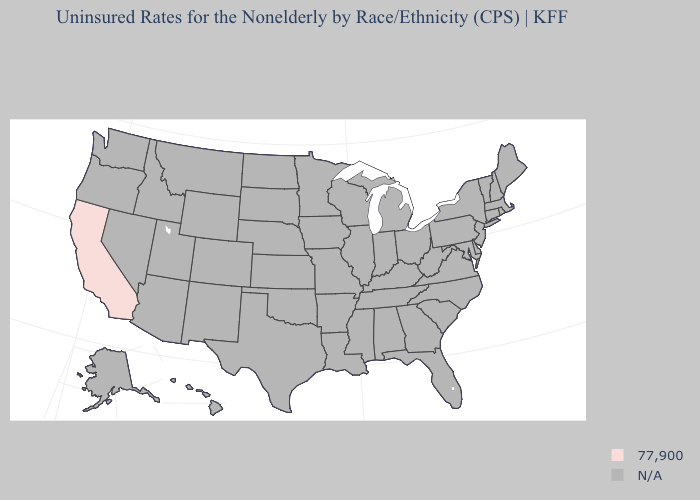Does the map have missing data?
Write a very short answer. Yes. Name the states that have a value in the range 77,900?
Be succinct. California. What is the value of Connecticut?
Short answer required. N/A. What is the value of Ohio?
Quick response, please. N/A. How many symbols are there in the legend?
Answer briefly. 2. Does the first symbol in the legend represent the smallest category?
Be succinct. Yes. Name the states that have a value in the range 77,900?
Give a very brief answer. California. What is the highest value in the USA?
Be succinct. 77,900. Name the states that have a value in the range 77,900?
Quick response, please. California. How many symbols are there in the legend?
Give a very brief answer. 2. 